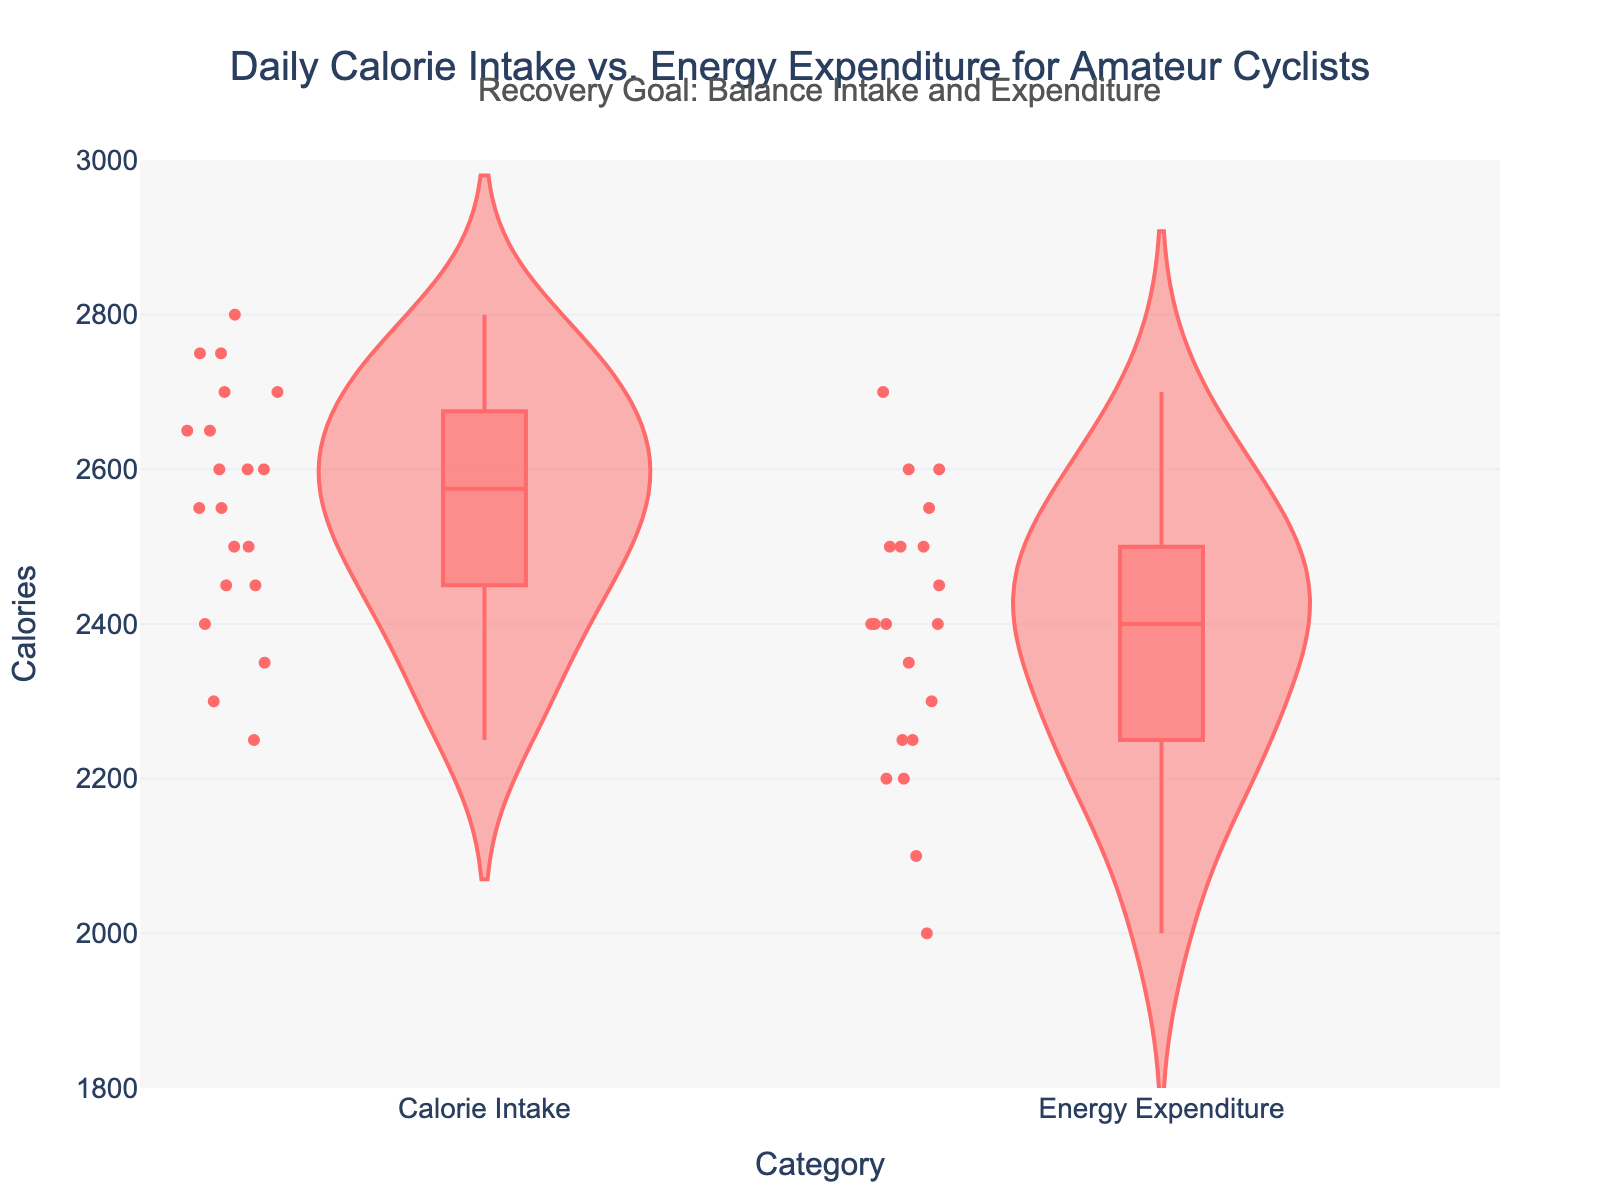What is the title of the figure? The title is displayed at the top of the figure.
Answer: "Daily Calorie Intake vs. Energy Expenditure for Amateur Cyclists" What are the categories shown on the y-axis? The y-axis labels show the two categories being compared.
Answer: "Calorie Intake" and "Energy Expenditure" What is the range of the y-axis values? The range is set based on the graph's y-axis scale.
Answer: 1800 to 3000 calories Which category shows a wider distribution of data points? Compare the width and shape of the violin plots for both categories.
Answer: Calorie Intake What is the median value of the "Energy Expenditure" category? The median value is indicated by the marker inside the box plot within the violin plot for Energy Expenditure.
Answer: Around 2400 calories Which category has a higher maximum value? Look at the topmost point within each violin plot.
Answer: Calorie Intake What is the average height of the two median values from the categories? Find the median values for both categories and calculate their average.
Answer: (2400 + 2500) / 2 = 2450 calories Are there any outliers in the "Calorie Intake" category? Check for any individual points that fall significantly outside of the main distribution in the violin plot for Calorie Intake.
Answer: Yes How does the general shape of the "Energy Expenditure" distribution compare to "Calorie Intake"? Analyze the overall shape and spread of the violin plots for each category.
Answer: Energy Expenditure is more evenly distributed What is the stated recovery goal in the annotation? Read the text annotation above the figure.
Answer: "Balance Intake and Expenditure" 